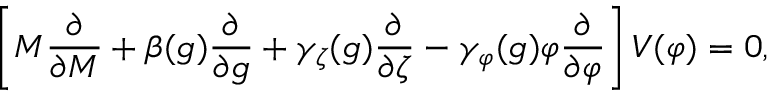Convert formula to latex. <formula><loc_0><loc_0><loc_500><loc_500>\left [ M { \frac { \partial } { \partial M } } + \beta ( g ) { \frac { \partial } { \partial g } } + \gamma _ { \zeta } ( g ) { \frac { \partial } { \partial \zeta } } - \gamma _ { \varphi } ( g ) \varphi { \frac { \partial } { \partial \varphi } } \right ] V ( \varphi ) = 0 ,</formula> 